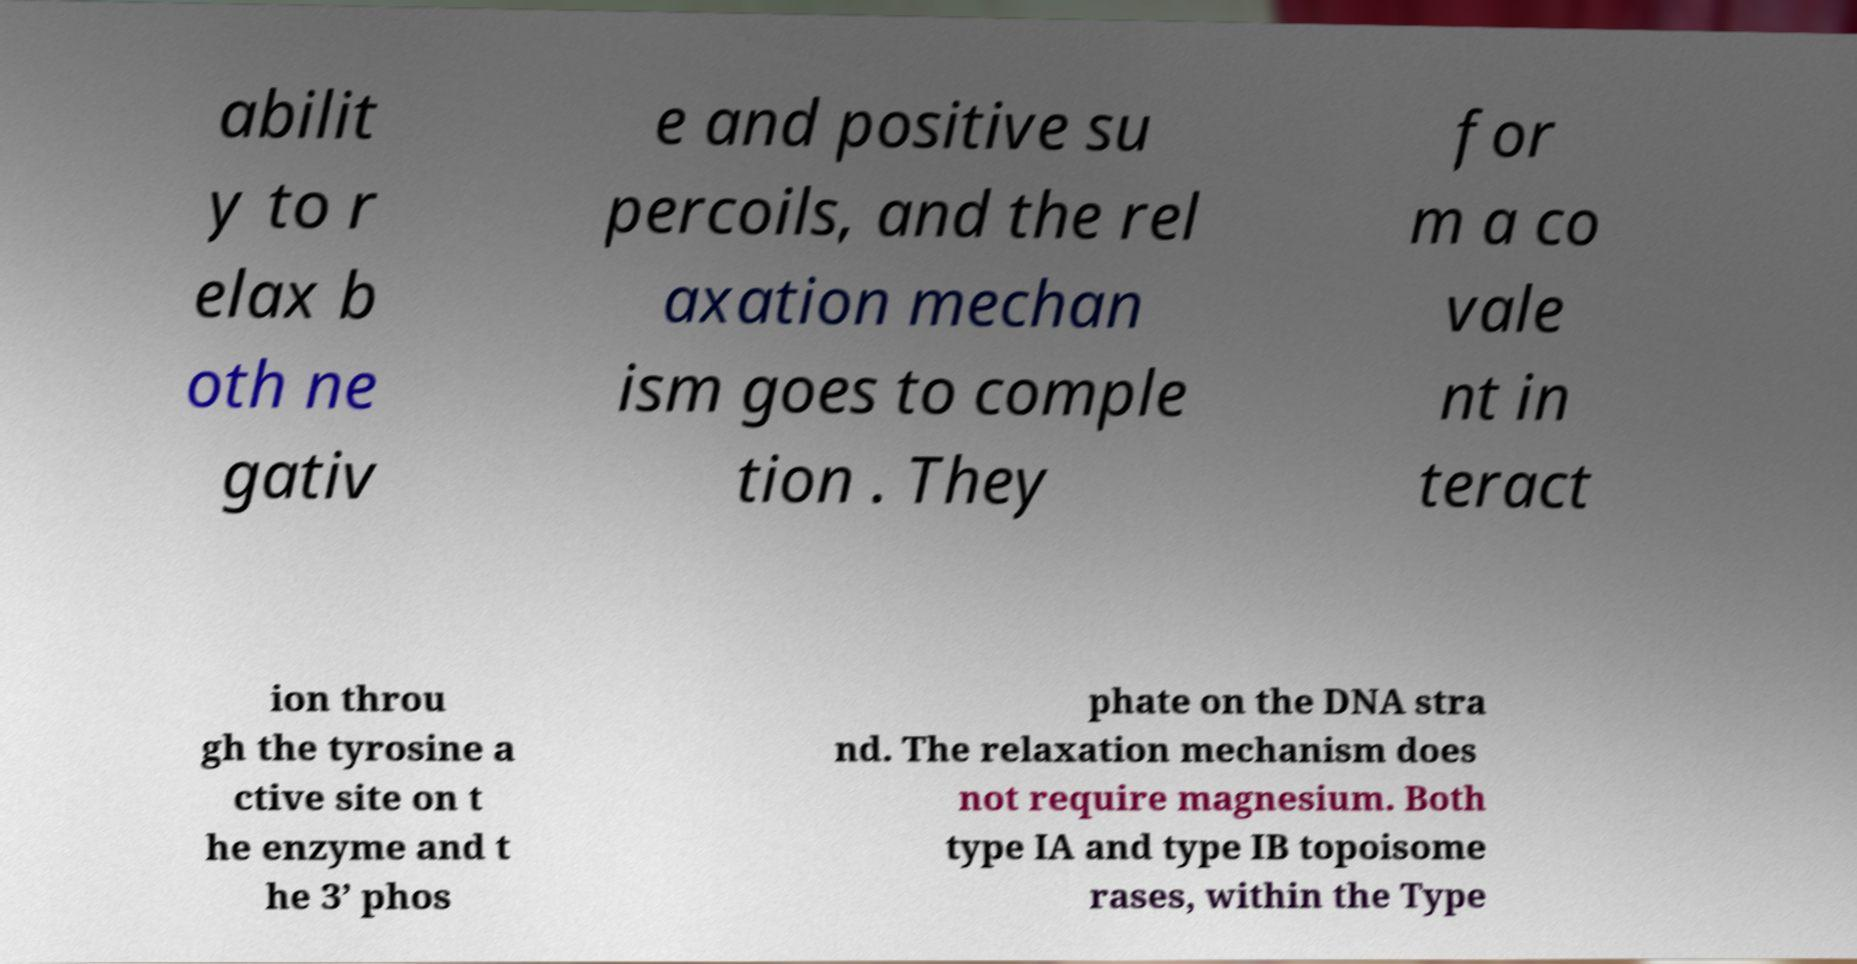Can you read and provide the text displayed in the image?This photo seems to have some interesting text. Can you extract and type it out for me? abilit y to r elax b oth ne gativ e and positive su percoils, and the rel axation mechan ism goes to comple tion . They for m a co vale nt in teract ion throu gh the tyrosine a ctive site on t he enzyme and t he 3’ phos phate on the DNA stra nd. The relaxation mechanism does not require magnesium. Both type IA and type IB topoisome rases, within the Type 